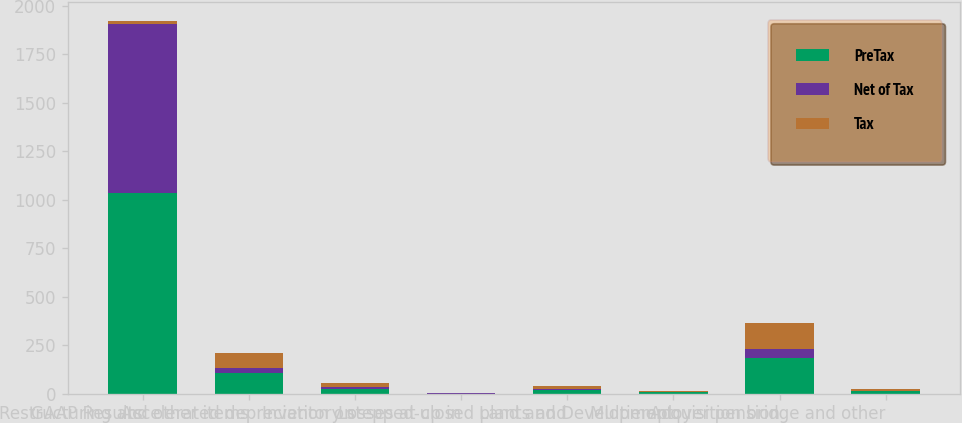Convert chart. <chart><loc_0><loc_0><loc_500><loc_500><stacked_bar_chart><ecel><fcel>GAAP Results<fcel>Restructuring and other items<fcel>Accelerated depreciation on<fcel>Inventory stepped-up in<fcel>Losses at closed plants and<fcel>Land and Development<fcel>Multiemployer pension<fcel>Acquisition bridge and other<nl><fcel>PreTax<fcel>1034.8<fcel>105.4<fcel>27<fcel>1<fcel>19.4<fcel>6.9<fcel>183.3<fcel>12<nl><fcel>Net of Tax<fcel>874.5<fcel>26.3<fcel>7.4<fcel>0.3<fcel>5<fcel>1.6<fcel>47.7<fcel>3.1<nl><fcel>Tax<fcel>14.4<fcel>79.1<fcel>19.6<fcel>0.7<fcel>14.4<fcel>5.3<fcel>135.6<fcel>8.9<nl></chart> 